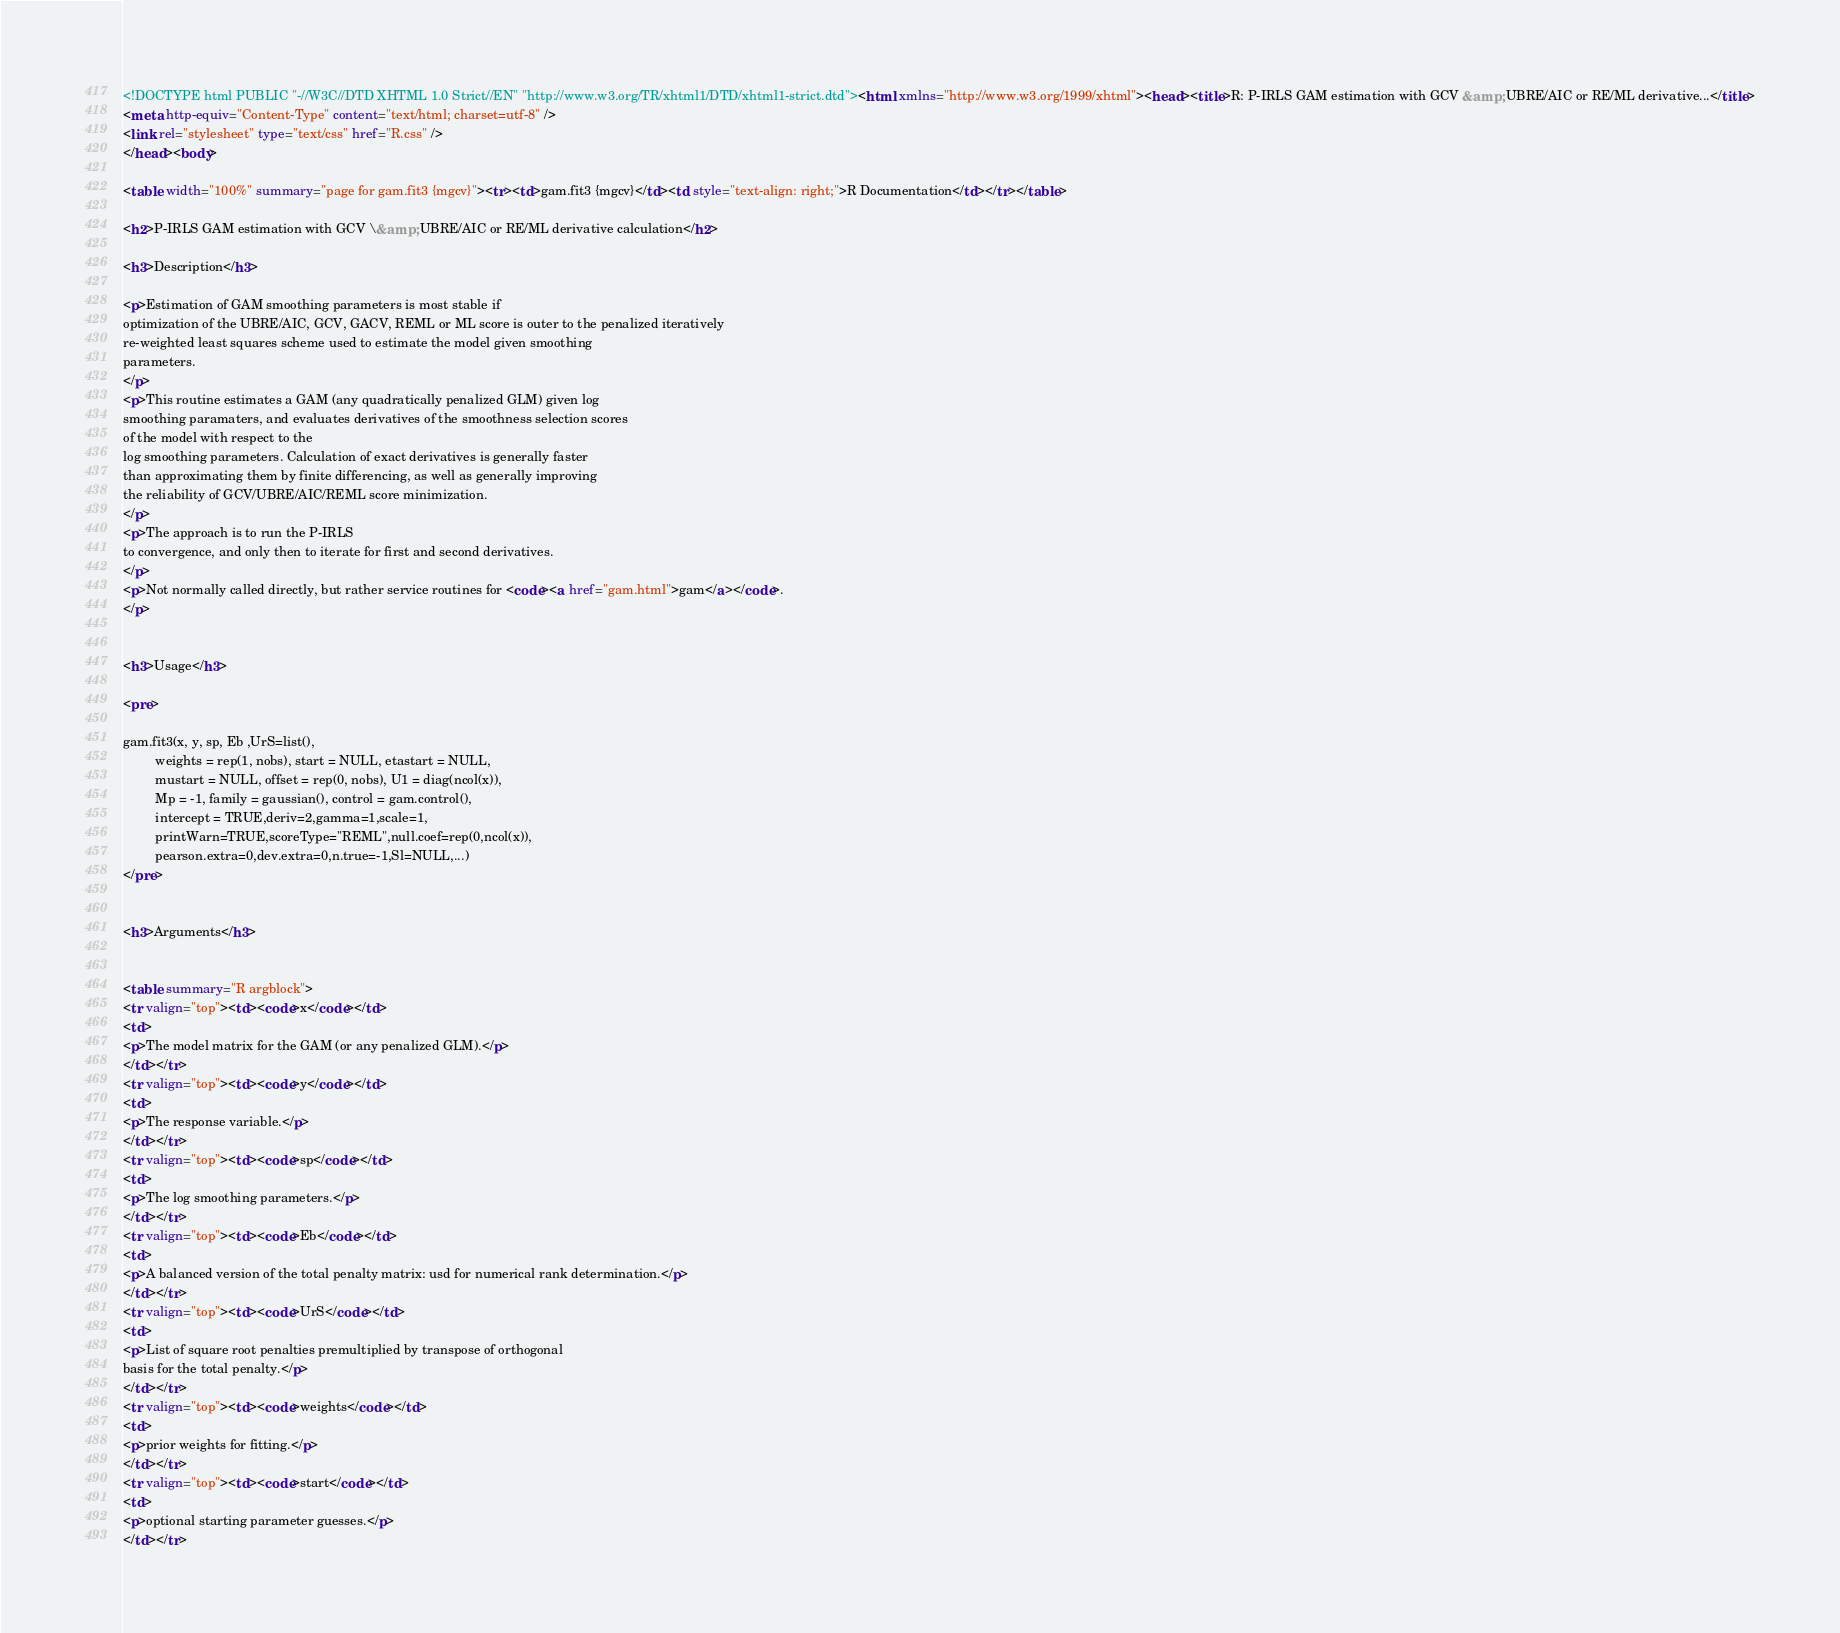Convert code to text. <code><loc_0><loc_0><loc_500><loc_500><_HTML_><!DOCTYPE html PUBLIC "-//W3C//DTD XHTML 1.0 Strict//EN" "http://www.w3.org/TR/xhtml1/DTD/xhtml1-strict.dtd"><html xmlns="http://www.w3.org/1999/xhtml"><head><title>R: P-IRLS GAM estimation with GCV &amp; UBRE/AIC or RE/ML derivative...</title>
<meta http-equiv="Content-Type" content="text/html; charset=utf-8" />
<link rel="stylesheet" type="text/css" href="R.css" />
</head><body>

<table width="100%" summary="page for gam.fit3 {mgcv}"><tr><td>gam.fit3 {mgcv}</td><td style="text-align: right;">R Documentation</td></tr></table>

<h2>P-IRLS GAM estimation with GCV \&amp; UBRE/AIC or RE/ML derivative calculation</h2>

<h3>Description</h3>

<p>Estimation of GAM smoothing parameters is most stable if
optimization of the UBRE/AIC, GCV, GACV, REML or ML score is outer to the penalized iteratively
re-weighted least squares scheme used to estimate the model given smoothing 
parameters.
</p>
<p>This routine estimates a GAM (any quadratically penalized GLM) given log 
smoothing paramaters, and evaluates derivatives of the smoothness selection scores 
of the model with respect to the
log smoothing parameters. Calculation of exact derivatives is generally faster
than approximating them by finite differencing, as well as generally improving
the reliability of GCV/UBRE/AIC/REML score minimization.
</p>
<p>The approach is to run the P-IRLS
to convergence, and only then to iterate for first and second derivatives. 
</p>
<p>Not normally called directly, but rather service routines for <code><a href="gam.html">gam</a></code>.
</p>


<h3>Usage</h3>

<pre>

gam.fit3(x, y, sp, Eb ,UrS=list(), 
         weights = rep(1, nobs), start = NULL, etastart = NULL, 
         mustart = NULL, offset = rep(0, nobs), U1 = diag(ncol(x)), 
         Mp = -1, family = gaussian(), control = gam.control(), 
         intercept = TRUE,deriv=2,gamma=1,scale=1,
         printWarn=TRUE,scoreType="REML",null.coef=rep(0,ncol(x)),
         pearson.extra=0,dev.extra=0,n.true=-1,Sl=NULL,...)
</pre>


<h3>Arguments</h3>

 
<table summary="R argblock">
<tr valign="top"><td><code>x</code></td>
<td>
<p>The model matrix for the GAM (or any penalized GLM).</p>
</td></tr>
<tr valign="top"><td><code>y</code></td>
<td>
<p>The response variable.</p>
</td></tr>
<tr valign="top"><td><code>sp</code></td>
<td>
<p>The log smoothing parameters.</p>
</td></tr>
<tr valign="top"><td><code>Eb</code></td>
<td>
<p>A balanced version of the total penalty matrix: usd for numerical rank determination.</p>
</td></tr>
<tr valign="top"><td><code>UrS</code></td>
<td>
<p>List of square root penalties premultiplied by transpose of orthogonal
basis for the total penalty.</p>
</td></tr>
<tr valign="top"><td><code>weights</code></td>
<td>
<p>prior weights for fitting.</p>
</td></tr>
<tr valign="top"><td><code>start</code></td>
<td>
<p>optional starting parameter guesses.</p>
</td></tr> </code> 